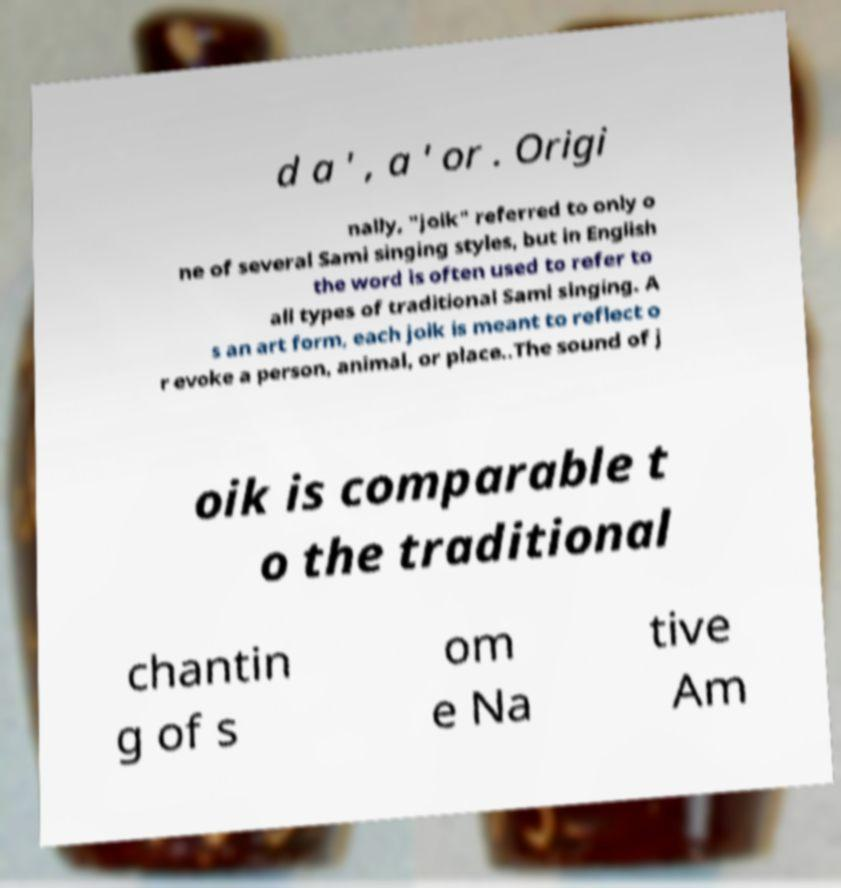Can you read and provide the text displayed in the image?This photo seems to have some interesting text. Can you extract and type it out for me? d a ' , a ' or . Origi nally, "joik" referred to only o ne of several Sami singing styles, but in English the word is often used to refer to all types of traditional Sami singing. A s an art form, each joik is meant to reflect o r evoke a person, animal, or place..The sound of j oik is comparable t o the traditional chantin g of s om e Na tive Am 